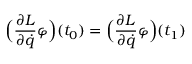Convert formula to latex. <formula><loc_0><loc_0><loc_500><loc_500>{ \left ( } { \frac { \partial L } { \partial { \dot { q } } } } \varphi { \right ) } ( t _ { 0 } ) = { \left ( } { \frac { \partial L } { \partial { \dot { q } } } } \varphi { \right ) } ( t _ { 1 } )</formula> 